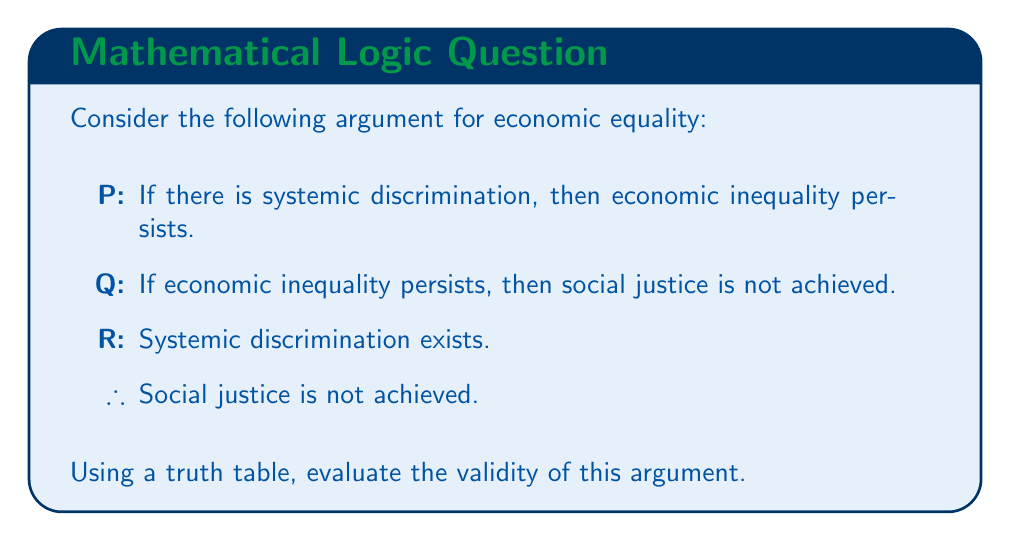Can you answer this question? To evaluate the validity of this argument using a truth table, we need to follow these steps:

1. Identify the premises and conclusion:
   Premise 1: $P \rightarrow Q$ (If systemic discrimination, then economic inequality persists)
   Premise 2: $Q \rightarrow R$ (If economic inequality persists, then social justice is not achieved)
   Premise 3: $P$ (Systemic discrimination exists)
   Conclusion: $R$ (Social justice is not achieved)

2. Construct a truth table with columns for P, Q, R, and the logical connectives:

   | P | Q | R | $P \rightarrow Q$ | $Q \rightarrow R$ | $P \land (P \rightarrow Q) \land (Q \rightarrow R)$ | R |
   |---|---|---|-------------------|-------------------|-----------------------------------------------------|---|
   | T | T | T | T                 | T                 | T                                                   | T |
   | T | T | F | T                 | F                 | F                                                   | F |
   | T | F | T | F                 | T                 | F                                                   | T |
   | T | F | F | F                 | T                 | F                                                   | F |
   | F | T | T | T                 | T                 | F                                                   | T |
   | F | T | F | T                 | F                 | F                                                   | F |
   | F | F | T | T                 | T                 | F                                                   | T |
   | F | F | F | T                 | T                 | F                                                   | F |

3. Evaluate the truth values for each row:
   - $P \rightarrow Q$ is true except when P is true and Q is false
   - $Q \rightarrow R$ is true except when Q is true and R is false
   - The conjunction of all premises $(P \land (P \rightarrow Q) \land (Q \rightarrow R))$ is true only in the first row

4. Check if the conclusion (R) is true in all rows where the premises are true:
   In the only row where all premises are true (row 1), the conclusion R is also true.

5. Determine validity:
   An argument is valid if the conclusion is true in all cases where the premises are true. In this case, the conclusion R is true in the only row where all premises are true.
Answer: The argument is valid. The truth table shows that when all premises are true (P is true, $P \rightarrow Q$ is true, and $Q \rightarrow R$ is true), the conclusion R is also true. This demonstrates that if the premises are accepted as true, the conclusion necessarily follows, making the argument for economic equality logically valid. 